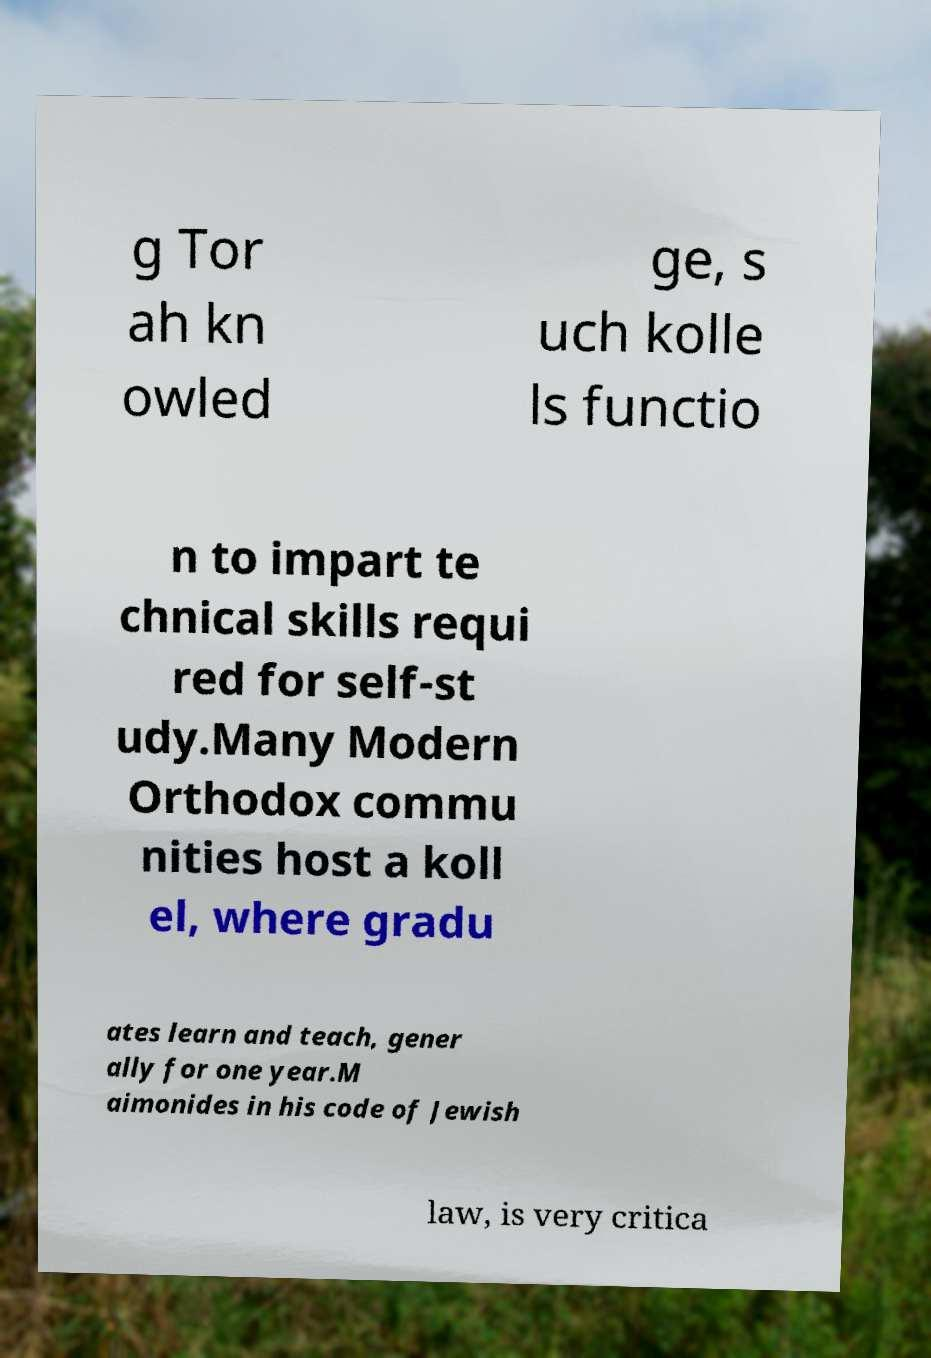There's text embedded in this image that I need extracted. Can you transcribe it verbatim? g Tor ah kn owled ge, s uch kolle ls functio n to impart te chnical skills requi red for self-st udy.Many Modern Orthodox commu nities host a koll el, where gradu ates learn and teach, gener ally for one year.M aimonides in his code of Jewish law, is very critica 